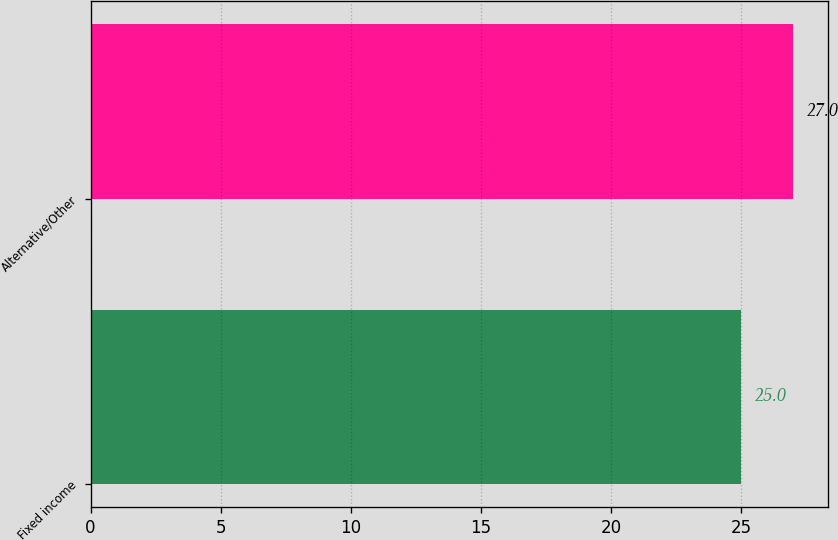<chart> <loc_0><loc_0><loc_500><loc_500><bar_chart><fcel>Fixed income<fcel>Alternative/Other<nl><fcel>25<fcel>27<nl></chart> 